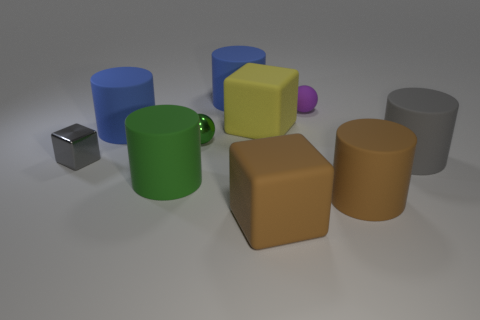What is the shape of the blue thing that is in front of the cylinder that is behind the purple sphere?
Offer a terse response. Cylinder. Is there any other thing that has the same shape as the small gray thing?
Give a very brief answer. Yes. Are there more yellow rubber things that are in front of the small purple matte ball than green cylinders?
Your answer should be very brief. No. How many big gray things are left of the ball behind the tiny green object?
Ensure brevity in your answer.  0. What is the shape of the green thing in front of the small metal cube left of the matte object that is right of the large brown cylinder?
Give a very brief answer. Cylinder. What size is the purple object?
Keep it short and to the point. Small. Are there any small cyan cylinders made of the same material as the big green object?
Offer a terse response. No. The green object that is the same shape as the tiny purple matte thing is what size?
Make the answer very short. Small. Are there an equal number of small green metallic objects to the right of the big yellow cube and small objects?
Provide a short and direct response. No. Is the shape of the large rubber object that is to the right of the large brown rubber cylinder the same as  the small green object?
Make the answer very short. No. 